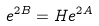<formula> <loc_0><loc_0><loc_500><loc_500>e ^ { 2 B } = H e ^ { 2 A }</formula> 